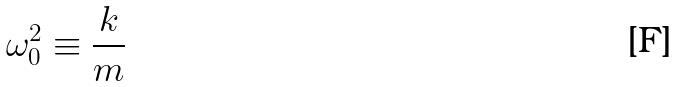Convert formula to latex. <formula><loc_0><loc_0><loc_500><loc_500>\omega _ { 0 } ^ { 2 } \equiv \frac { k } { m }</formula> 